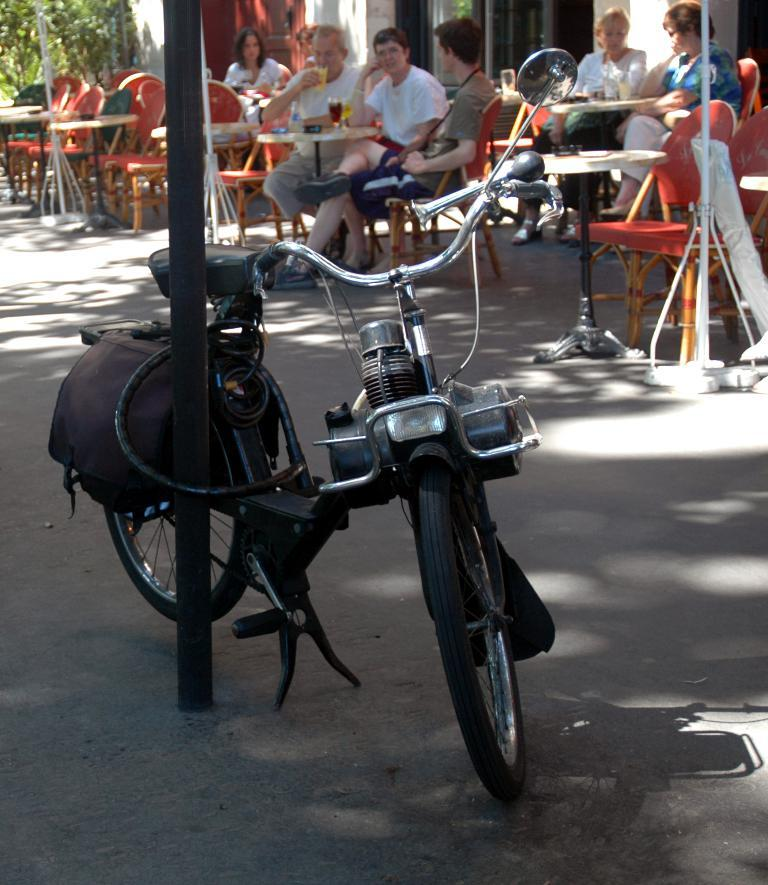Who or what can be seen in the image? There are people in the image. What type of furniture is present in the image? There are tables and chairs in the image. What type of structure is visible in the image? There is a building in the image. What can be seen in the background on the left side? There is a tree in the background on the left side. What mode of transportation is in the front of the image? There is a bicycle in the front of the image. Who is wearing a crown in the image? There is no one wearing a crown in the image. What color is the sky in the image? The provided facts do not mention the color of the sky, so we cannot determine its color from the image. 